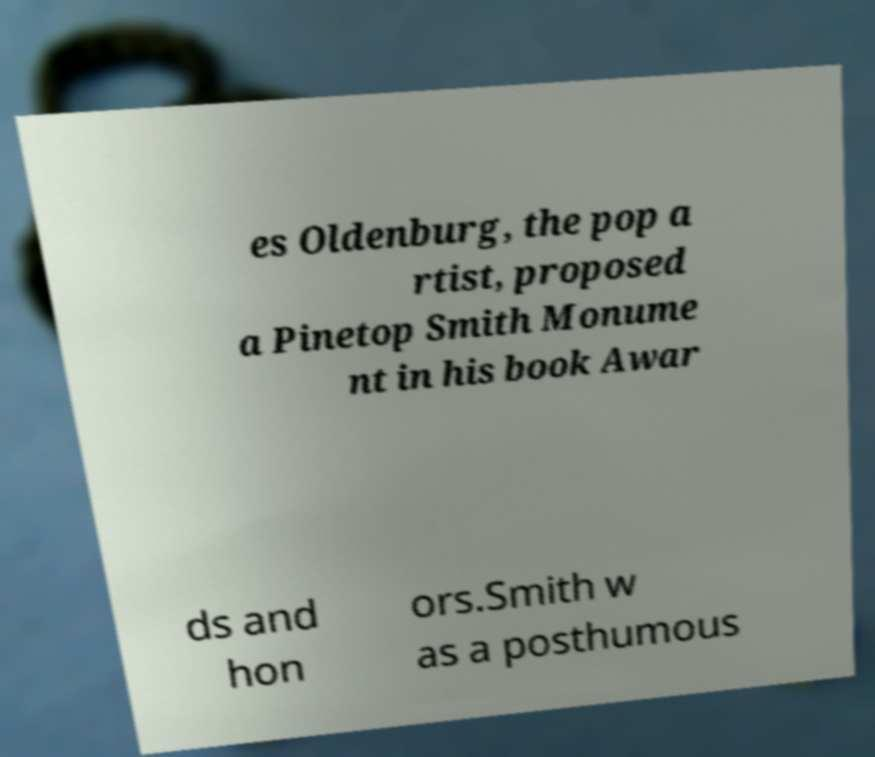Could you assist in decoding the text presented in this image and type it out clearly? es Oldenburg, the pop a rtist, proposed a Pinetop Smith Monume nt in his book Awar ds and hon ors.Smith w as a posthumous 